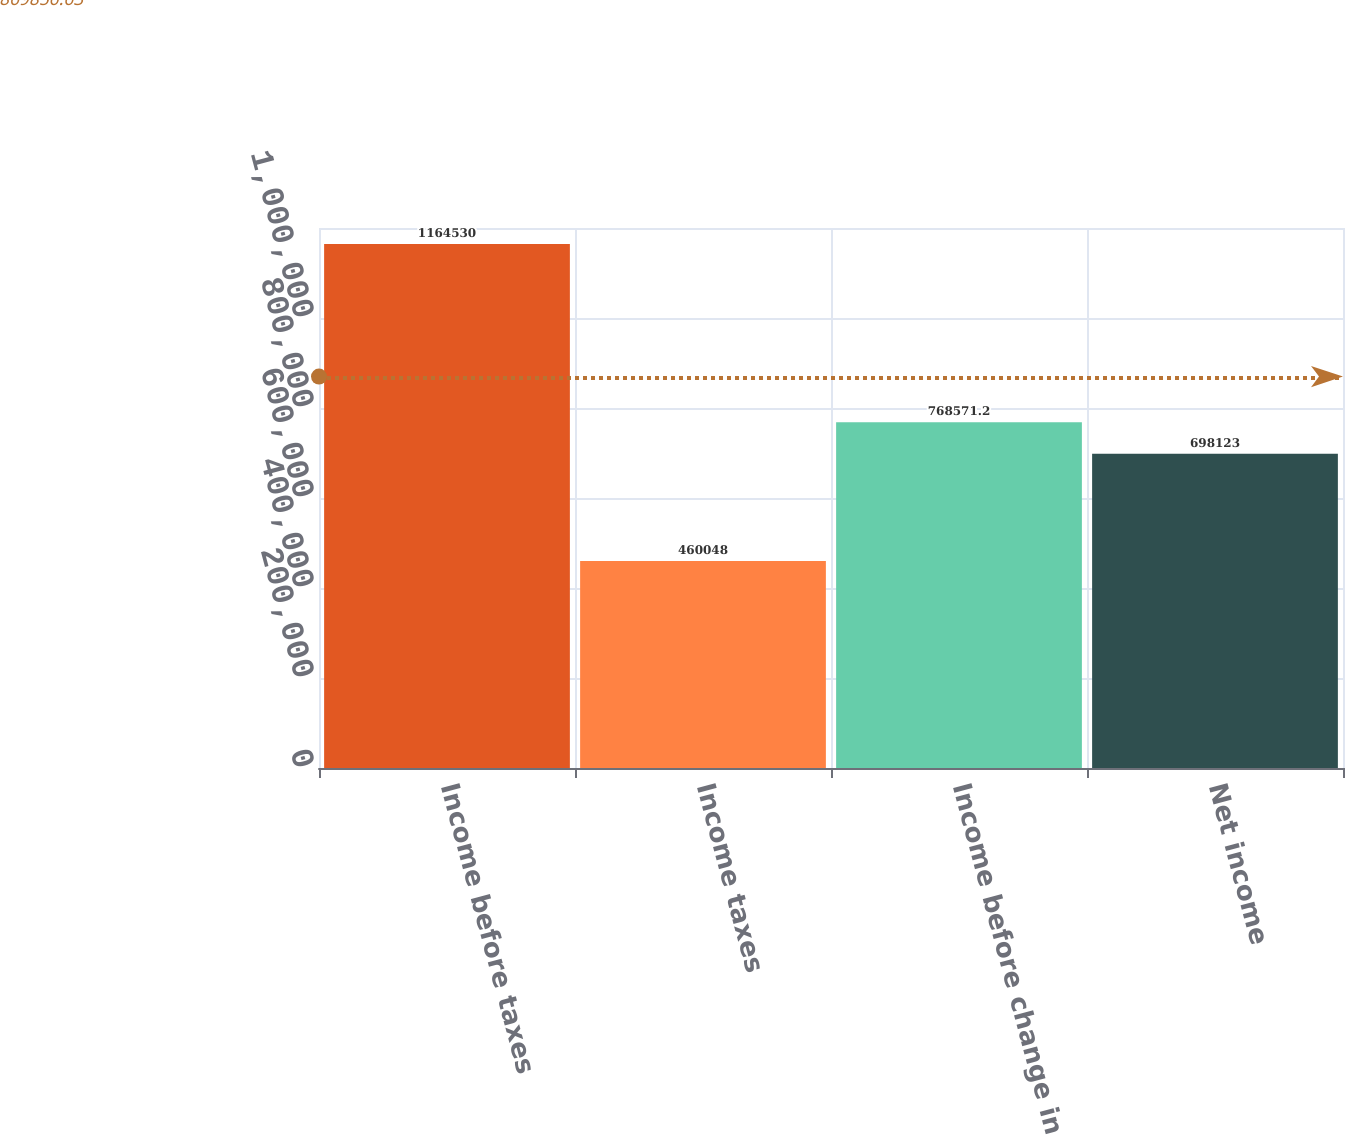<chart> <loc_0><loc_0><loc_500><loc_500><bar_chart><fcel>Income before taxes<fcel>Income taxes<fcel>Income before change in<fcel>Net income<nl><fcel>1.16453e+06<fcel>460048<fcel>768571<fcel>698123<nl></chart> 